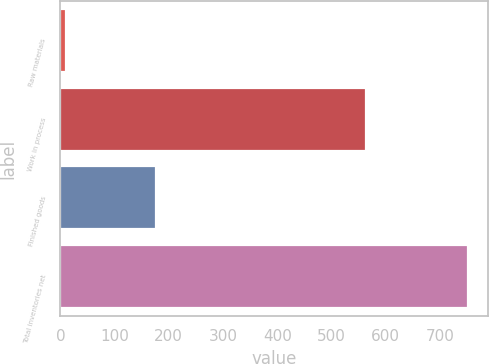Convert chart. <chart><loc_0><loc_0><loc_500><loc_500><bar_chart><fcel>Raw materials<fcel>Work in process<fcel>Finished goods<fcel>Total inventories net<nl><fcel>11<fcel>564<fcel>176<fcel>751<nl></chart> 